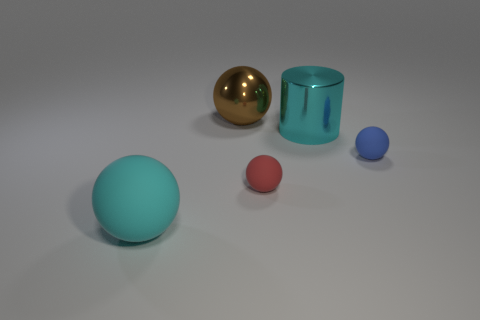How many objects are big red rubber spheres or balls on the right side of the cyan shiny object?
Give a very brief answer. 1. There is a ball that is behind the blue sphere; is its size the same as the large cyan matte thing?
Your answer should be compact. Yes. How many other objects are there of the same shape as the red object?
Offer a terse response. 3. How many blue things are either matte spheres or large metallic balls?
Provide a succinct answer. 1. There is a large ball behind the large cyan matte object; is its color the same as the big matte ball?
Your answer should be very brief. No. What shape is the cyan object that is made of the same material as the brown thing?
Give a very brief answer. Cylinder. There is a ball that is left of the red ball and on the right side of the big cyan rubber sphere; what is its color?
Your answer should be very brief. Brown. There is a metallic thing on the left side of the large metal thing that is in front of the brown metallic sphere; what size is it?
Ensure brevity in your answer.  Large. Is there a big matte thing that has the same color as the large cylinder?
Provide a short and direct response. Yes. Are there the same number of big cyan matte things that are behind the blue ball and blue rubber spheres?
Offer a terse response. No. 